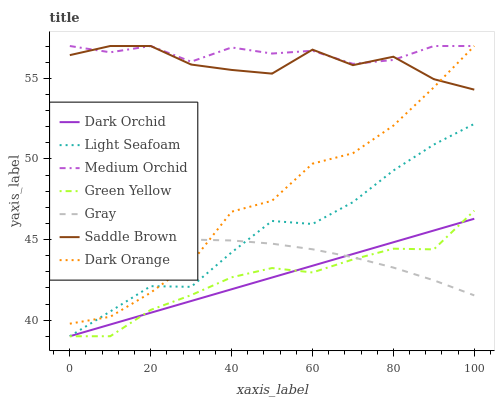Does Dark Orange have the minimum area under the curve?
Answer yes or no. No. Does Dark Orange have the maximum area under the curve?
Answer yes or no. No. Is Green Yellow the smoothest?
Answer yes or no. No. Is Green Yellow the roughest?
Answer yes or no. No. Does Dark Orange have the lowest value?
Answer yes or no. No. Does Green Yellow have the highest value?
Answer yes or no. No. Is Green Yellow less than Medium Orchid?
Answer yes or no. Yes. Is Saddle Brown greater than Light Seafoam?
Answer yes or no. Yes. Does Green Yellow intersect Medium Orchid?
Answer yes or no. No. 